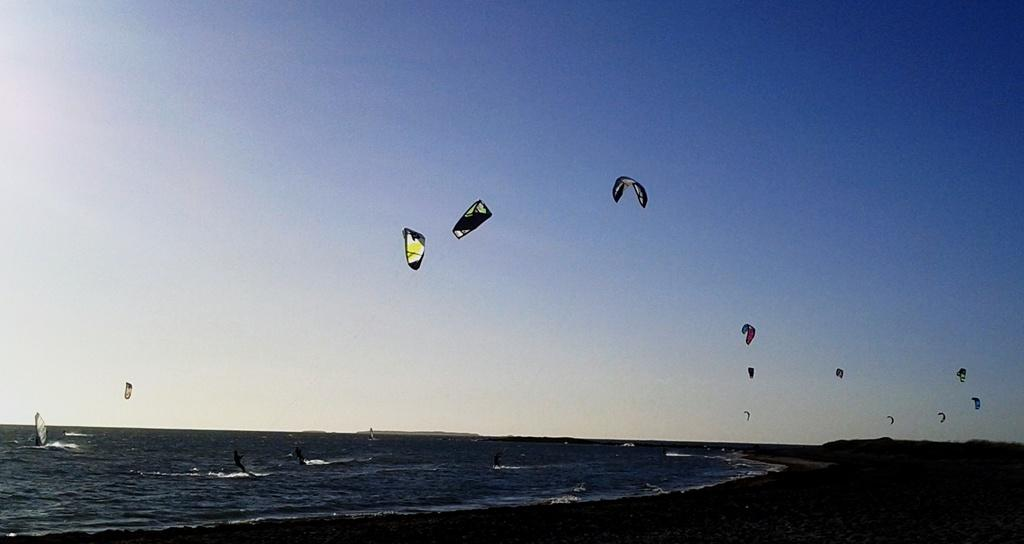What activity are the people in the image engaged in? The people in the image are paragliding. What type of landscape is visible in the image? The image appears to depict a sea. Are there any people on the water in the image? Yes, there are people on the water in the image. What type of location might this image represent? The image is likely of a seashore. What type of orange can be seen growing on the corn in the image? There is no orange or corn present in the image; it features paragliders flying over a sea. How far away is the distance between the paragliders and the people on the water in the image? The provided facts do not include information about the distance between the paragliders and the people on the water, so it cannot be determined from the image. 